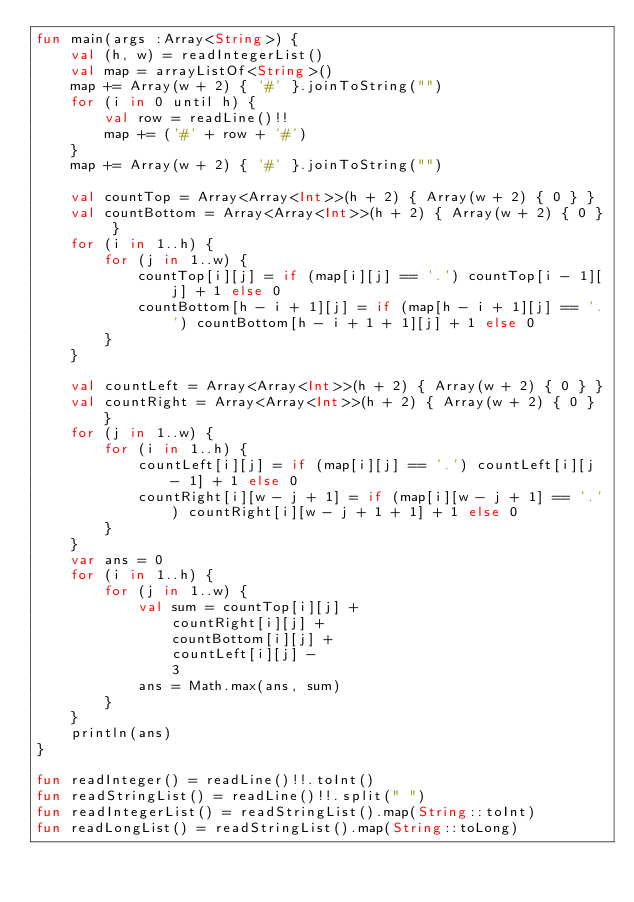<code> <loc_0><loc_0><loc_500><loc_500><_Kotlin_>fun main(args :Array<String>) {
    val (h, w) = readIntegerList()
    val map = arrayListOf<String>()
    map += Array(w + 2) { '#' }.joinToString("")
    for (i in 0 until h) {
        val row = readLine()!!
        map += ('#' + row + '#')
    }
    map += Array(w + 2) { '#' }.joinToString("")

    val countTop = Array<Array<Int>>(h + 2) { Array(w + 2) { 0 } }
    val countBottom = Array<Array<Int>>(h + 2) { Array(w + 2) { 0 } }
    for (i in 1..h) {
        for (j in 1..w) {
            countTop[i][j] = if (map[i][j] == '.') countTop[i - 1][j] + 1 else 0
            countBottom[h - i + 1][j] = if (map[h - i + 1][j] == '.') countBottom[h - i + 1 + 1][j] + 1 else 0
        }
    }

    val countLeft = Array<Array<Int>>(h + 2) { Array(w + 2) { 0 } }
    val countRight = Array<Array<Int>>(h + 2) { Array(w + 2) { 0 } }
    for (j in 1..w) {
        for (i in 1..h) {
            countLeft[i][j] = if (map[i][j] == '.') countLeft[i][j - 1] + 1 else 0
            countRight[i][w - j + 1] = if (map[i][w - j + 1] == '.') countRight[i][w - j + 1 + 1] + 1 else 0
        }
    }
    var ans = 0
    for (i in 1..h) {
        for (j in 1..w) {
            val sum = countTop[i][j] +
                countRight[i][j] +
                countBottom[i][j] +
                countLeft[i][j] -
                3
            ans = Math.max(ans, sum)
        }
    }
    println(ans)
}

fun readInteger() = readLine()!!.toInt()
fun readStringList() = readLine()!!.split(" ")
fun readIntegerList() = readStringList().map(String::toInt)
fun readLongList() = readStringList().map(String::toLong)
</code> 